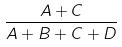<formula> <loc_0><loc_0><loc_500><loc_500>\frac { A + C } { A + B + C + D }</formula> 